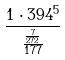<formula> <loc_0><loc_0><loc_500><loc_500>\frac { 1 \cdot 3 9 4 ^ { 5 } } { \frac { \frac { 7 } { 2 7 2 } } { 1 7 7 } }</formula> 